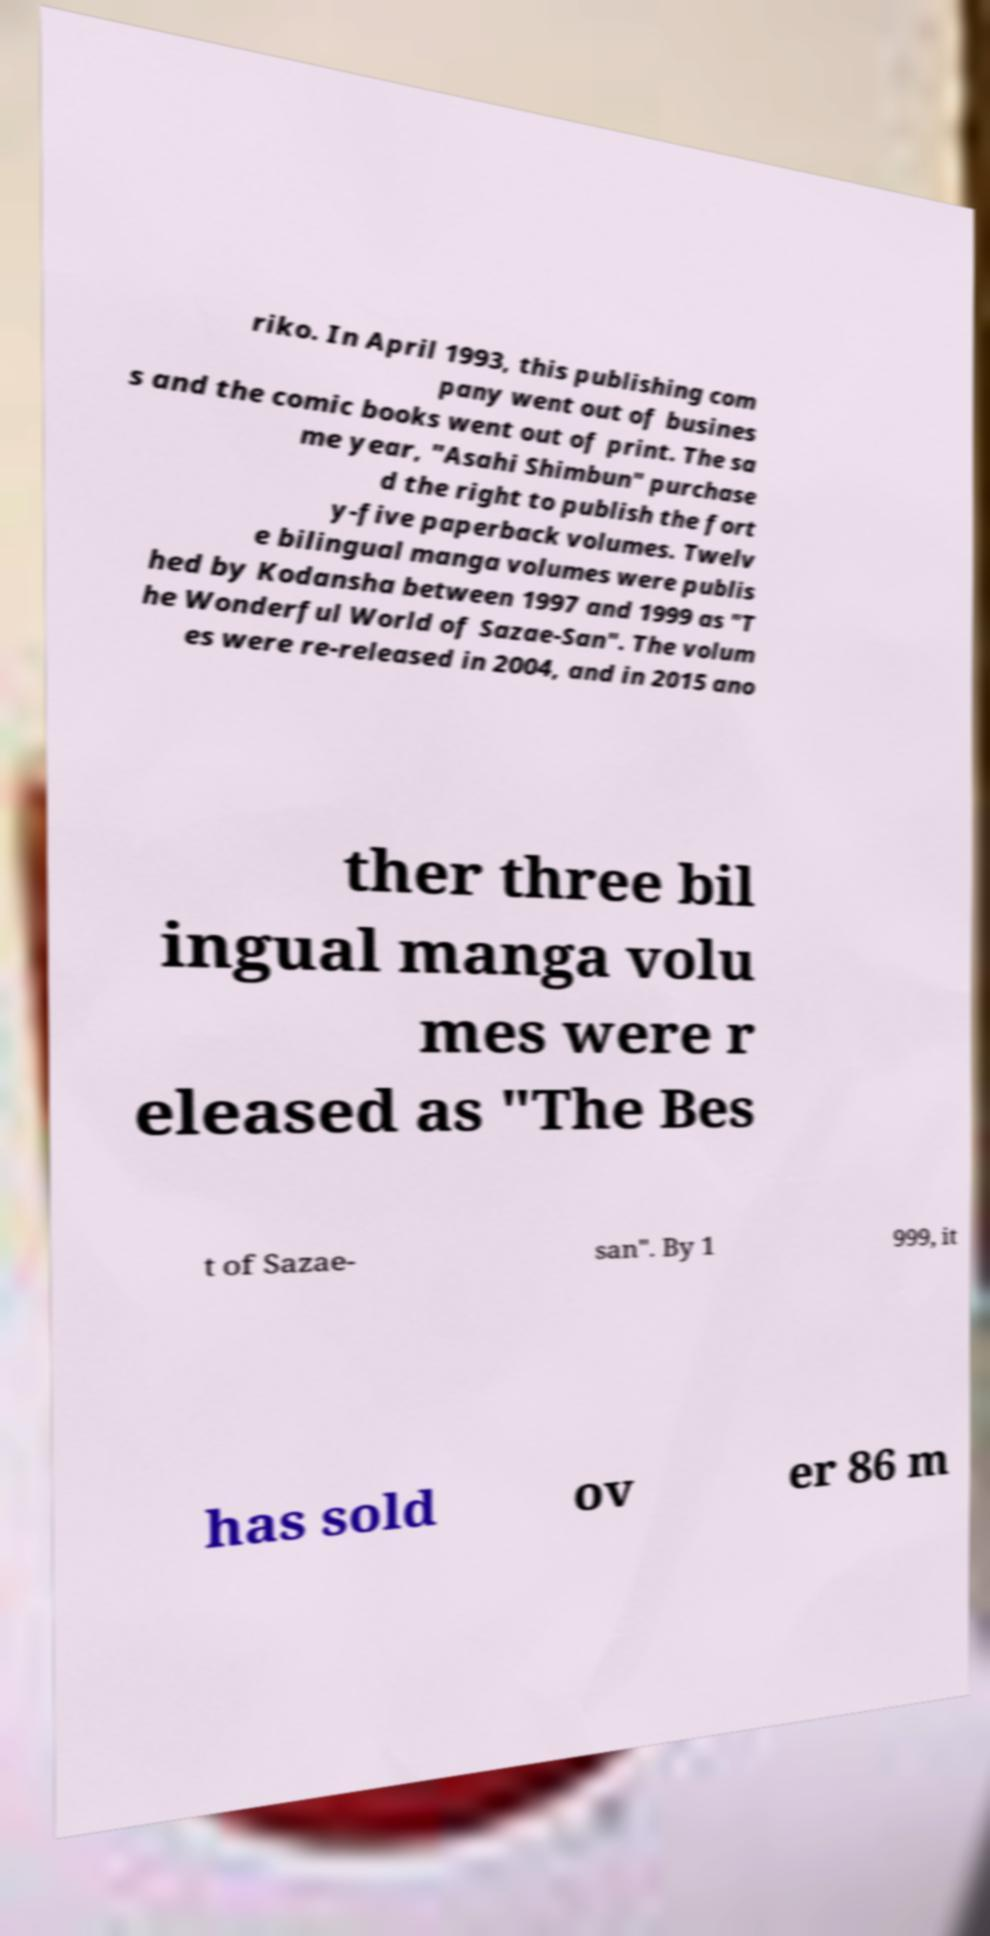What messages or text are displayed in this image? I need them in a readable, typed format. riko. In April 1993, this publishing com pany went out of busines s and the comic books went out of print. The sa me year, "Asahi Shimbun" purchase d the right to publish the fort y-five paperback volumes. Twelv e bilingual manga volumes were publis hed by Kodansha between 1997 and 1999 as "T he Wonderful World of Sazae-San". The volum es were re-released in 2004, and in 2015 ano ther three bil ingual manga volu mes were r eleased as "The Bes t of Sazae- san". By 1 999, it has sold ov er 86 m 